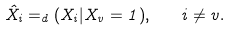<formula> <loc_0><loc_0><loc_500><loc_500>\hat { X } _ { i } = _ { d } ( X _ { i } | X _ { v } = 1 ) , \quad i \neq v .</formula> 